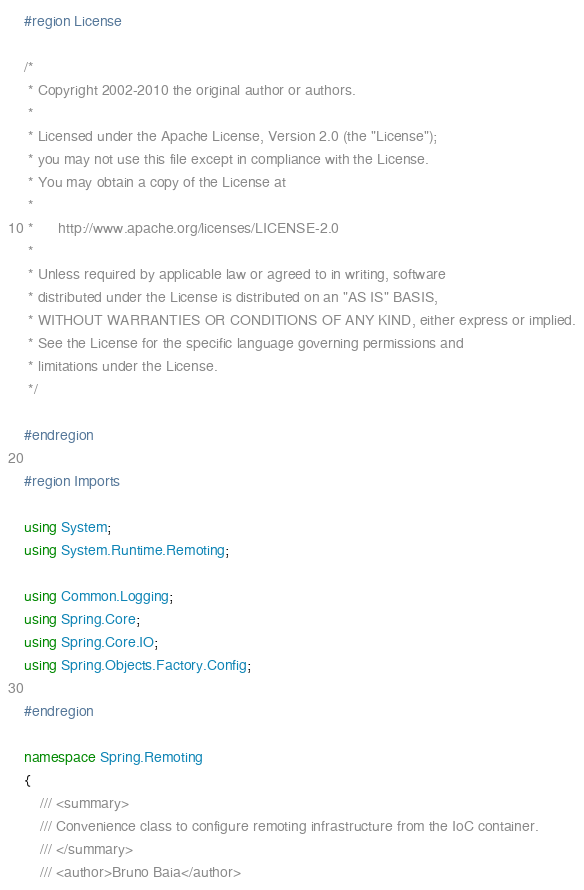<code> <loc_0><loc_0><loc_500><loc_500><_C#_>#region License

/*
 * Copyright 2002-2010 the original author or authors.
 *
 * Licensed under the Apache License, Version 2.0 (the "License");
 * you may not use this file except in compliance with the License.
 * You may obtain a copy of the License at
 *
 *      http://www.apache.org/licenses/LICENSE-2.0
 *
 * Unless required by applicable law or agreed to in writing, software
 * distributed under the License is distributed on an "AS IS" BASIS,
 * WITHOUT WARRANTIES OR CONDITIONS OF ANY KIND, either express or implied.
 * See the License for the specific language governing permissions and
 * limitations under the License.
 */

#endregion

#region Imports

using System;
using System.Runtime.Remoting;

using Common.Logging;
using Spring.Core;
using Spring.Core.IO;
using Spring.Objects.Factory.Config;

#endregion

namespace Spring.Remoting
{
    /// <summary>
    /// Convenience class to configure remoting infrastructure from the IoC container.
    /// </summary>
    /// <author>Bruno Baia</author></code> 